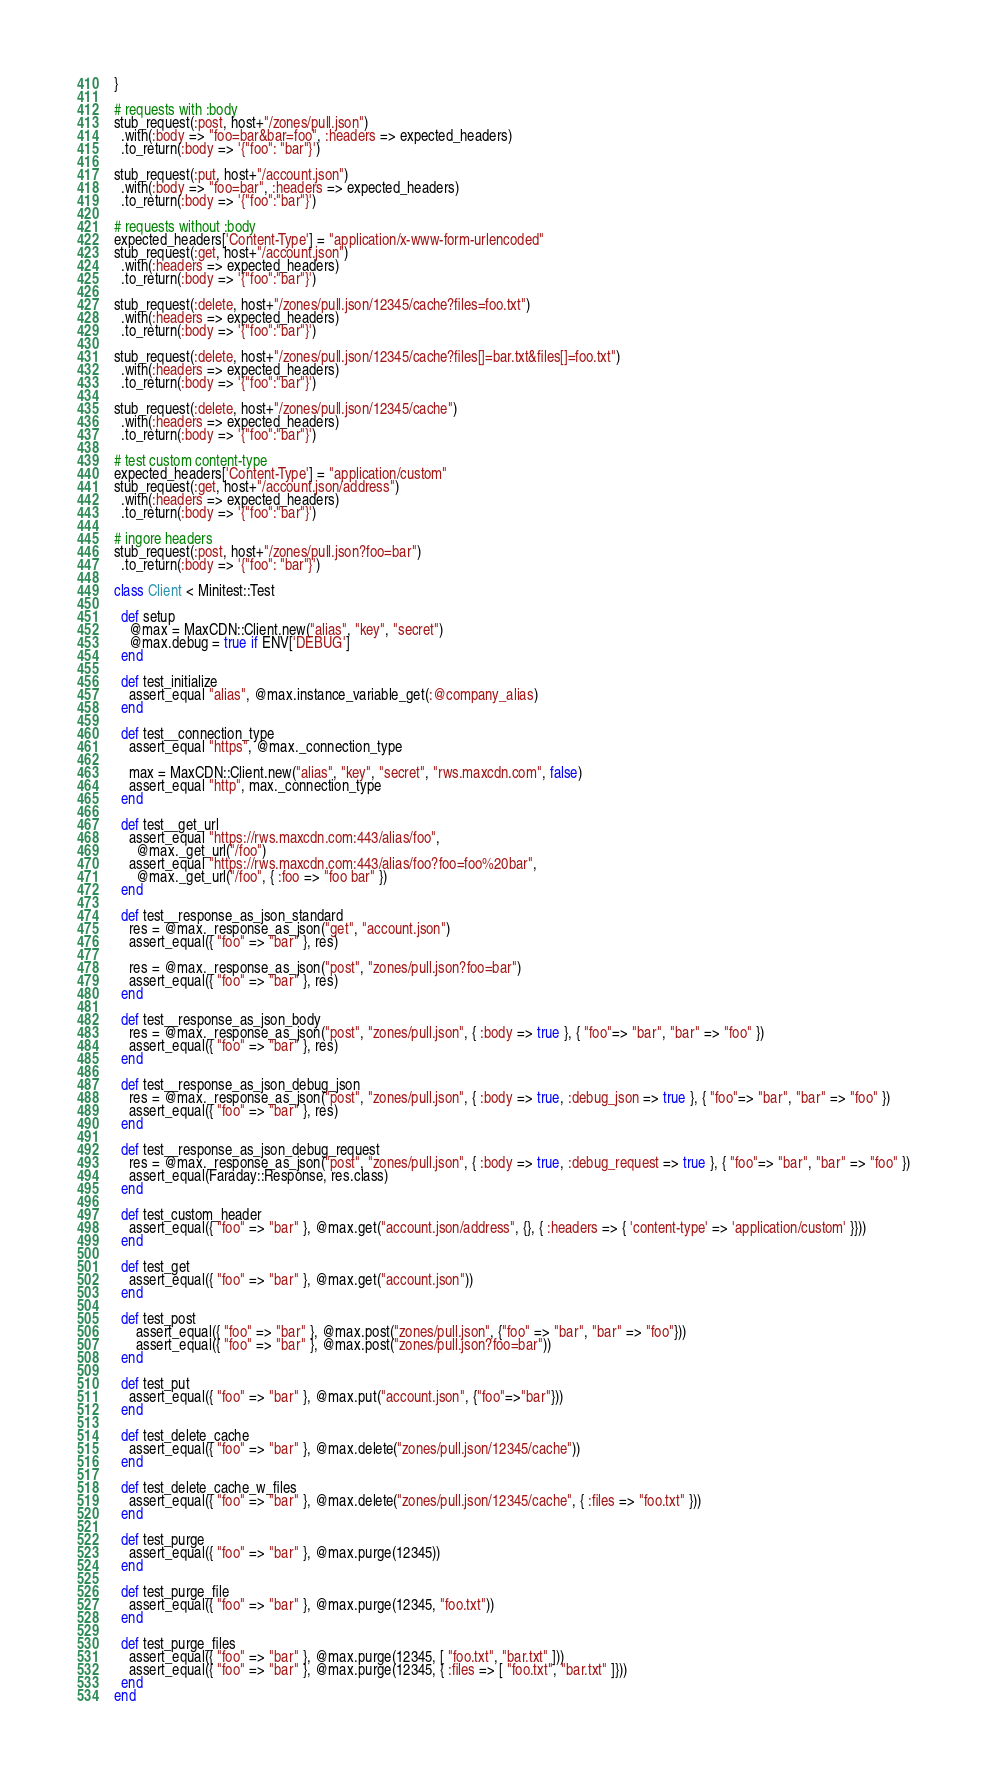Convert code to text. <code><loc_0><loc_0><loc_500><loc_500><_Ruby_>}

# requests with :body
stub_request(:post, host+"/zones/pull.json")
  .with(:body => "foo=bar&bar=foo", :headers => expected_headers)
  .to_return(:body => '{"foo": "bar"}')

stub_request(:put, host+"/account.json")
  .with(:body => "foo=bar", :headers => expected_headers)
  .to_return(:body => '{"foo":"bar"}')

# requests without :body
expected_headers['Content-Type'] = "application/x-www-form-urlencoded"
stub_request(:get, host+"/account.json")
  .with(:headers => expected_headers)
  .to_return(:body => '{"foo":"bar"}')

stub_request(:delete, host+"/zones/pull.json/12345/cache?files=foo.txt")
  .with(:headers => expected_headers)
  .to_return(:body => '{"foo":"bar"}')

stub_request(:delete, host+"/zones/pull.json/12345/cache?files[]=bar.txt&files[]=foo.txt")
  .with(:headers => expected_headers)
  .to_return(:body => '{"foo":"bar"}')

stub_request(:delete, host+"/zones/pull.json/12345/cache")
  .with(:headers => expected_headers)
  .to_return(:body => '{"foo":"bar"}')

# test custom content-type
expected_headers['Content-Type'] = "application/custom"
stub_request(:get, host+"/account.json/address")
  .with(:headers => expected_headers)
  .to_return(:body => '{"foo":"bar"}')

# ingore headers
stub_request(:post, host+"/zones/pull.json?foo=bar")
  .to_return(:body => '{"foo": "bar"}')

class Client < Minitest::Test

  def setup
    @max = MaxCDN::Client.new("alias", "key", "secret")
    @max.debug = true if ENV['DEBUG']
  end

  def test_initialize
    assert_equal "alias", @max.instance_variable_get(:@company_alias)
  end

  def test__connection_type
    assert_equal "https", @max._connection_type

    max = MaxCDN::Client.new("alias", "key", "secret", "rws.maxcdn.com", false)
    assert_equal "http", max._connection_type
  end

  def test__get_url
    assert_equal "https://rws.maxcdn.com:443/alias/foo",
      @max._get_url("/foo")
    assert_equal "https://rws.maxcdn.com:443/alias/foo?foo=foo%20bar",
      @max._get_url("/foo", { :foo => "foo bar" })
  end

  def test__response_as_json_standard
    res = @max._response_as_json("get", "account.json")
    assert_equal({ "foo" => "bar" }, res)

    res = @max._response_as_json("post", "zones/pull.json?foo=bar")
    assert_equal({ "foo" => "bar" }, res)
  end

  def test__response_as_json_body
    res = @max._response_as_json("post", "zones/pull.json", { :body => true }, { "foo"=> "bar", "bar" => "foo" })
    assert_equal({ "foo" => "bar" }, res)
  end

  def test__response_as_json_debug_json
    res = @max._response_as_json("post", "zones/pull.json", { :body => true, :debug_json => true }, { "foo"=> "bar", "bar" => "foo" })
    assert_equal({ "foo" => "bar" }, res)
  end

  def test__response_as_json_debug_request
    res = @max._response_as_json("post", "zones/pull.json", { :body => true, :debug_request => true }, { "foo"=> "bar", "bar" => "foo" })
    assert_equal(Faraday::Response, res.class)
  end

  def test_custom_header
    assert_equal({ "foo" => "bar" }, @max.get("account.json/address", {}, { :headers => { 'content-type' => 'application/custom' }}))
  end

  def test_get
    assert_equal({ "foo" => "bar" }, @max.get("account.json"))
  end

  def test_post
      assert_equal({ "foo" => "bar" }, @max.post("zones/pull.json", {"foo" => "bar", "bar" => "foo"}))
      assert_equal({ "foo" => "bar" }, @max.post("zones/pull.json?foo=bar"))
  end

  def test_put
    assert_equal({ "foo" => "bar" }, @max.put("account.json", {"foo"=>"bar"}))
  end

  def test_delete_cache
    assert_equal({ "foo" => "bar" }, @max.delete("zones/pull.json/12345/cache"))
  end

  def test_delete_cache_w_files
    assert_equal({ "foo" => "bar" }, @max.delete("zones/pull.json/12345/cache", { :files => "foo.txt" }))
  end

  def test_purge
    assert_equal({ "foo" => "bar" }, @max.purge(12345))
  end

  def test_purge_file
    assert_equal({ "foo" => "bar" }, @max.purge(12345, "foo.txt"))
  end

  def test_purge_files
    assert_equal({ "foo" => "bar" }, @max.purge(12345, [ "foo.txt", "bar.txt" ]))
    assert_equal({ "foo" => "bar" }, @max.purge(12345, { :files => [ "foo.txt", "bar.txt" ]}))
  end
end

</code> 